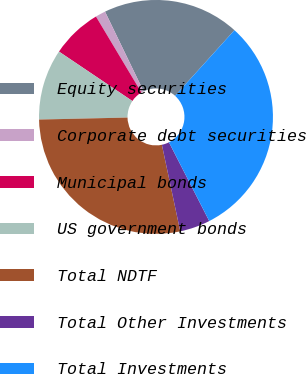<chart> <loc_0><loc_0><loc_500><loc_500><pie_chart><fcel>Equity securities<fcel>Corporate debt securities<fcel>Municipal bonds<fcel>US government bonds<fcel>Total NDTF<fcel>Total Other Investments<fcel>Total Investments<nl><fcel>18.88%<fcel>1.4%<fcel>6.99%<fcel>9.79%<fcel>27.97%<fcel>4.2%<fcel>30.77%<nl></chart> 